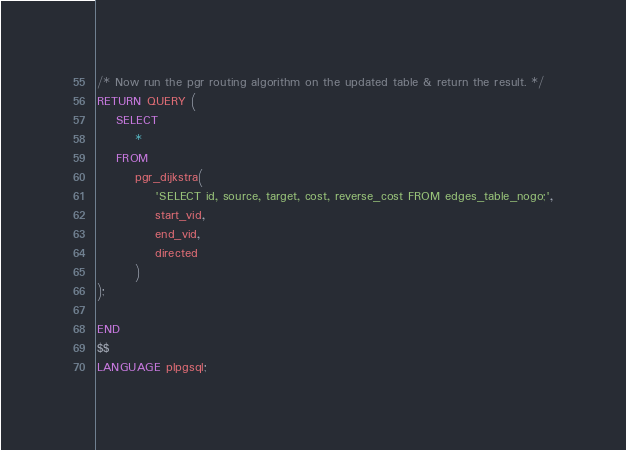Convert code to text. <code><loc_0><loc_0><loc_500><loc_500><_SQL_>
/* Now run the pgr routing algorithm on the updated table & return the result. */
RETURN QUERY (
	SELECT
		*
	FROM
		pgr_dijkstra(
			'SELECT id, source, target, cost, reverse_cost FROM edges_table_nogo;',
			start_vid,
			end_vid,
			directed
		)
);

END
$$
LANGUAGE plpgsql;
</code> 